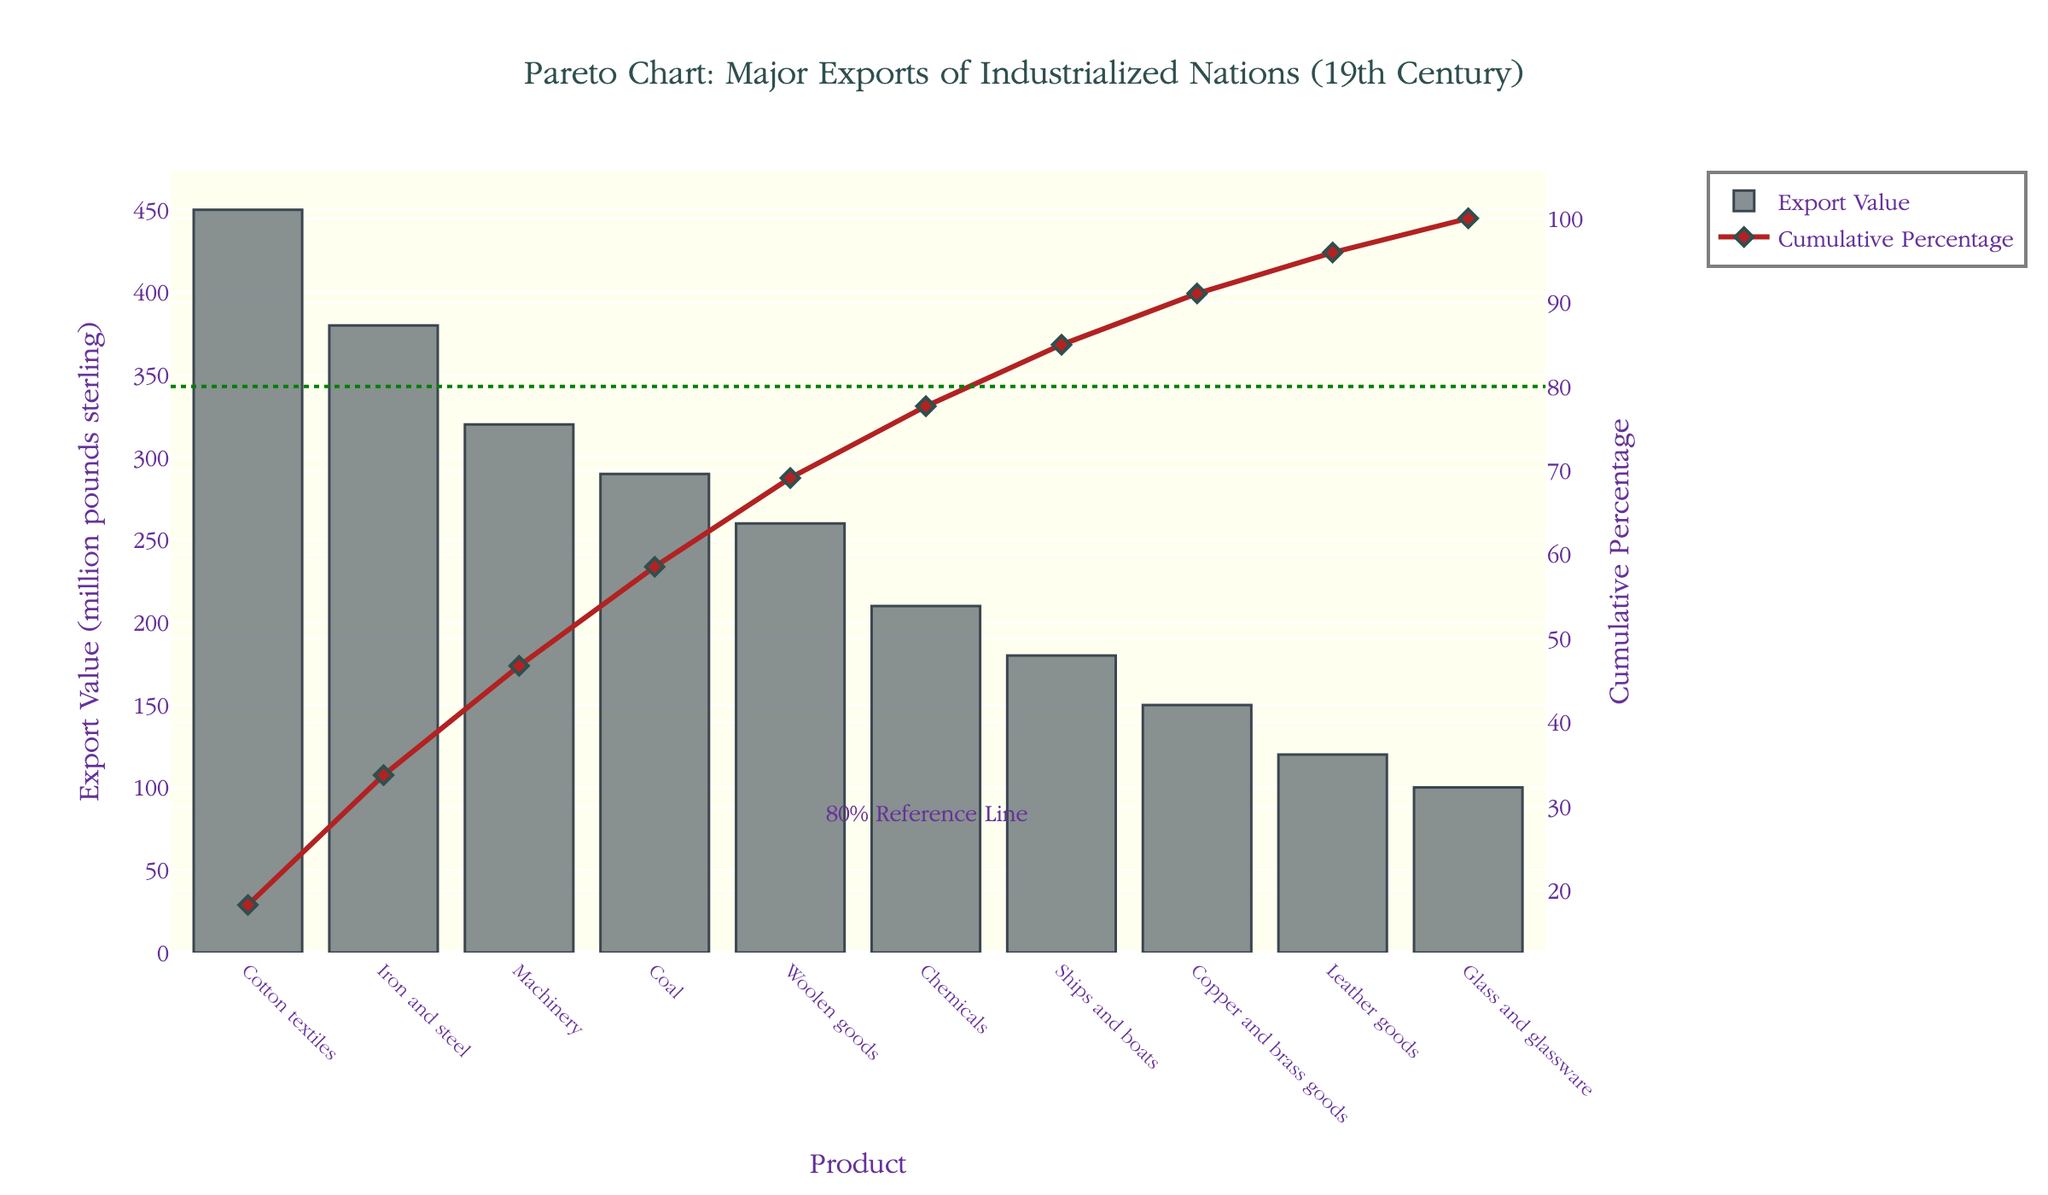What is the title of the chart? The title of the chart is displayed at the top center of the figure. The title text reads "Pareto Chart: Major Exports of Industrialized Nations (19th Century)".
Answer: Pareto Chart: Major Exports of Industrialized Nations (19th Century) Which product had the highest export value? The product with the highest export value is the one with the tallest bar in the bar chart. Cotton textiles had the highest export value at 450 million pounds sterling.
Answer: Cotton textiles What is the cumulative percentage for Machinery? To find the cumulative percentage for Machinery, locate the Machinery product on the x-axis and trace vertically to the line chart. The cumulative percentage for Machinery is approximately 61.27%.
Answer: 61.27% How many products have export values above 200 million pounds sterling? Identify all the bars that exceed the 200 million pounds sterling mark. Cotton textiles, Iron and steel, Machinery, and Coal have export values above 200 million pounds sterling. Count these four products.
Answer: Four What is the total export value of the top three products combined? The top three products are Cotton textiles, Iron and steel, and Machinery. Their individual values are 450, 380, and 320 million pounds sterling, respectively. Adding them together: 450 + 380 + 320 = 1150
Answer: 1150 million pounds sterling Which product appears just below the 80% reference line in the cumulative percentage? Identify where the 80% reference line intersects the cumulative percentage line. The product just below this line is Woolen goods.
Answer: Woolen goods What is the difference in export value between Coal and Copper and brass goods? The export value of Coal is 290 million pounds sterling and that of Copper and brass goods is 150 million pounds sterling. The difference is 290 - 150 = 140.
Answer: 140 million pounds sterling How does the export value of Ships and boats compare to Leather goods? The bar representing Ships and boats (180 million pounds sterling) is taller than the bar for Leather goods (120 million pounds sterling). Therefore, Ships and boats have a higher export value.
Answer: Ships and boats have a higher export value What's the cumulative percentage after the first five products on the list? Sum the values of the first five products (Cotton textiles, Iron and steel, Machinery, Coal, and Woolen goods) and divide by the total sum of all values, then multiply by 100. (450 + 380 + 320 + 290 + 260) / (450 + 380 + 320 + 290 + 260 + 210 + 180 + 150 + 120 + 100) * 100 = 1700 / 2460 * 100 ≈ 69.11%
Answer: 69.11% Which product marks the 50% cumulative percentage? To find the product that denotes the 50% cumulative percentage, trace horizontally from the 50% mark on the right y-axis to where it intersects the cumulative percentage line. It corresponds to Iron and steel.
Answer: Iron and steel 